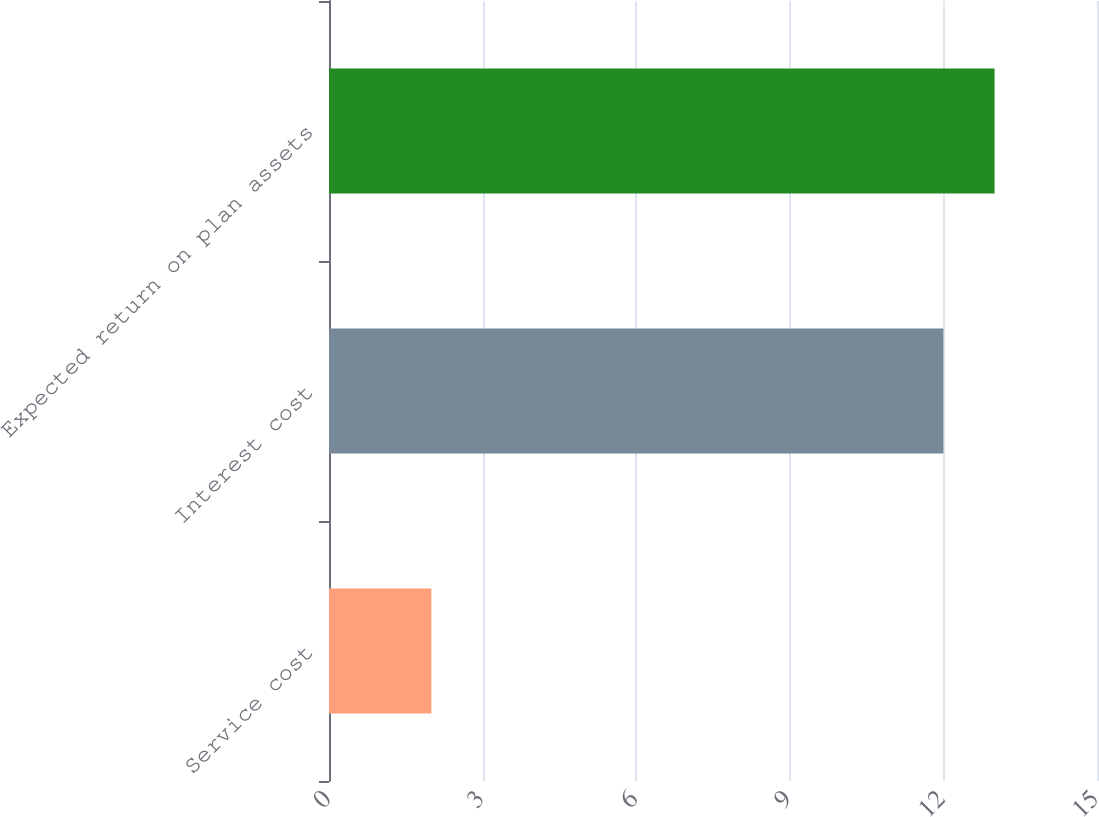<chart> <loc_0><loc_0><loc_500><loc_500><bar_chart><fcel>Service cost<fcel>Interest cost<fcel>Expected return on plan assets<nl><fcel>2<fcel>12<fcel>13<nl></chart> 